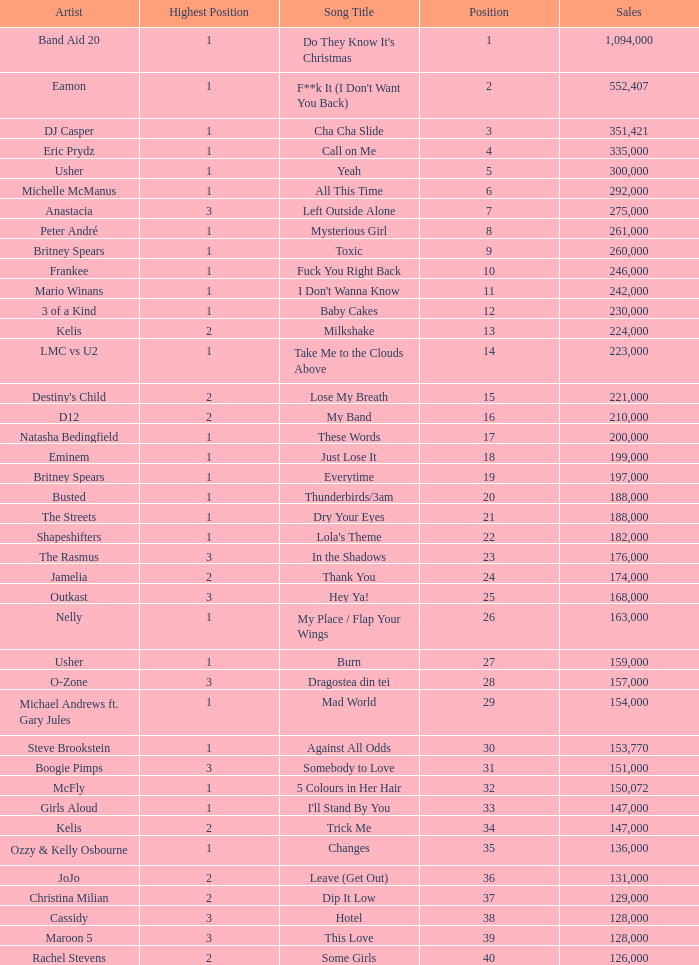I'm looking to parse the entire table for insights. Could you assist me with that? {'header': ['Artist', 'Highest Position', 'Song Title', 'Position', 'Sales'], 'rows': [['Band Aid 20', '1', "Do They Know It's Christmas", '1', '1,094,000'], ['Eamon', '1', "F**k It (I Don't Want You Back)", '2', '552,407'], ['DJ Casper', '1', 'Cha Cha Slide', '3', '351,421'], ['Eric Prydz', '1', 'Call on Me', '4', '335,000'], ['Usher', '1', 'Yeah', '5', '300,000'], ['Michelle McManus', '1', 'All This Time', '6', '292,000'], ['Anastacia', '3', 'Left Outside Alone', '7', '275,000'], ['Peter André', '1', 'Mysterious Girl', '8', '261,000'], ['Britney Spears', '1', 'Toxic', '9', '260,000'], ['Frankee', '1', 'Fuck You Right Back', '10', '246,000'], ['Mario Winans', '1', "I Don't Wanna Know", '11', '242,000'], ['3 of a Kind', '1', 'Baby Cakes', '12', '230,000'], ['Kelis', '2', 'Milkshake', '13', '224,000'], ['LMC vs U2', '1', 'Take Me to the Clouds Above', '14', '223,000'], ["Destiny's Child", '2', 'Lose My Breath', '15', '221,000'], ['D12', '2', 'My Band', '16', '210,000'], ['Natasha Bedingfield', '1', 'These Words', '17', '200,000'], ['Eminem', '1', 'Just Lose It', '18', '199,000'], ['Britney Spears', '1', 'Everytime', '19', '197,000'], ['Busted', '1', 'Thunderbirds/3am', '20', '188,000'], ['The Streets', '1', 'Dry Your Eyes', '21', '188,000'], ['Shapeshifters', '1', "Lola's Theme", '22', '182,000'], ['The Rasmus', '3', 'In the Shadows', '23', '176,000'], ['Jamelia', '2', 'Thank You', '24', '174,000'], ['Outkast', '3', 'Hey Ya!', '25', '168,000'], ['Nelly', '1', 'My Place / Flap Your Wings', '26', '163,000'], ['Usher', '1', 'Burn', '27', '159,000'], ['O-Zone', '3', 'Dragostea din tei', '28', '157,000'], ['Michael Andrews ft. Gary Jules', '1', 'Mad World', '29', '154,000'], ['Steve Brookstein', '1', 'Against All Odds', '30', '153,770'], ['Boogie Pimps', '3', 'Somebody to Love', '31', '151,000'], ['McFly', '1', '5 Colours in Her Hair', '32', '150,072'], ['Girls Aloud', '1', "I'll Stand By You", '33', '147,000'], ['Kelis', '2', 'Trick Me', '34', '147,000'], ['Ozzy & Kelly Osbourne', '1', 'Changes', '35', '136,000'], ['JoJo', '2', 'Leave (Get Out)', '36', '131,000'], ['Christina Milian', '2', 'Dip It Low', '37', '129,000'], ['Cassidy', '3', 'Hotel', '38', '128,000'], ['Maroon 5', '3', 'This Love', '39', '128,000'], ['Rachel Stevens', '2', 'Some Girls', '40', '126,000']]} What were the sales for Dj Casper when he was in a position lower than 13? 351421.0. 